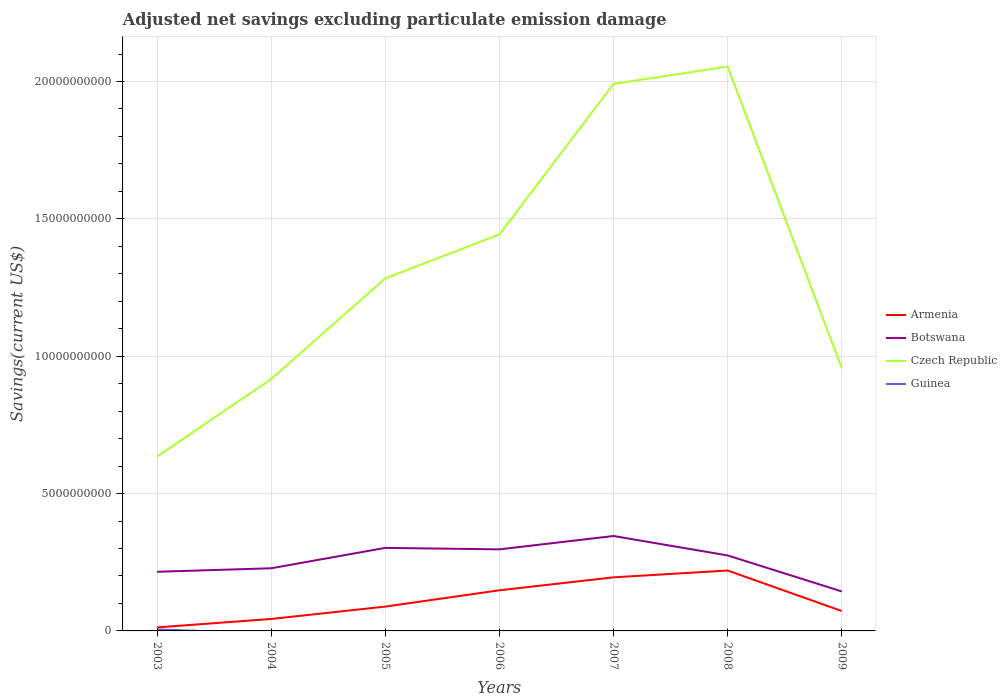How many different coloured lines are there?
Your answer should be very brief. 4. Is the number of lines equal to the number of legend labels?
Your response must be concise. No. Across all years, what is the maximum adjusted net savings in Botswana?
Provide a short and direct response. 1.44e+09. What is the total adjusted net savings in Armenia in the graph?
Provide a succinct answer. -7.58e+08. What is the difference between the highest and the second highest adjusted net savings in Czech Republic?
Provide a short and direct response. 1.42e+1. Is the adjusted net savings in Czech Republic strictly greater than the adjusted net savings in Armenia over the years?
Offer a very short reply. No. How many years are there in the graph?
Make the answer very short. 7. What is the difference between two consecutive major ticks on the Y-axis?
Offer a very short reply. 5.00e+09. Are the values on the major ticks of Y-axis written in scientific E-notation?
Your response must be concise. No. Does the graph contain any zero values?
Your answer should be very brief. Yes. Where does the legend appear in the graph?
Provide a short and direct response. Center right. How are the legend labels stacked?
Offer a very short reply. Vertical. What is the title of the graph?
Keep it short and to the point. Adjusted net savings excluding particulate emission damage. What is the label or title of the Y-axis?
Provide a succinct answer. Savings(current US$). What is the Savings(current US$) in Armenia in 2003?
Ensure brevity in your answer.  1.28e+08. What is the Savings(current US$) of Botswana in 2003?
Provide a succinct answer. 2.15e+09. What is the Savings(current US$) of Czech Republic in 2003?
Your response must be concise. 6.35e+09. What is the Savings(current US$) of Guinea in 2003?
Your answer should be compact. 5.63e+07. What is the Savings(current US$) in Armenia in 2004?
Provide a short and direct response. 4.36e+08. What is the Savings(current US$) of Botswana in 2004?
Provide a succinct answer. 2.28e+09. What is the Savings(current US$) in Czech Republic in 2004?
Your answer should be very brief. 9.17e+09. What is the Savings(current US$) of Armenia in 2005?
Give a very brief answer. 8.86e+08. What is the Savings(current US$) of Botswana in 2005?
Give a very brief answer. 3.02e+09. What is the Savings(current US$) of Czech Republic in 2005?
Your answer should be compact. 1.28e+1. What is the Savings(current US$) of Guinea in 2005?
Make the answer very short. 0. What is the Savings(current US$) in Armenia in 2006?
Ensure brevity in your answer.  1.48e+09. What is the Savings(current US$) of Botswana in 2006?
Provide a short and direct response. 2.97e+09. What is the Savings(current US$) in Czech Republic in 2006?
Give a very brief answer. 1.44e+1. What is the Savings(current US$) in Armenia in 2007?
Provide a short and direct response. 1.95e+09. What is the Savings(current US$) of Botswana in 2007?
Your response must be concise. 3.46e+09. What is the Savings(current US$) of Czech Republic in 2007?
Offer a terse response. 1.99e+1. What is the Savings(current US$) in Armenia in 2008?
Give a very brief answer. 2.20e+09. What is the Savings(current US$) in Botswana in 2008?
Your response must be concise. 2.75e+09. What is the Savings(current US$) of Czech Republic in 2008?
Keep it short and to the point. 2.05e+1. What is the Savings(current US$) in Armenia in 2009?
Offer a very short reply. 7.25e+08. What is the Savings(current US$) of Botswana in 2009?
Offer a terse response. 1.44e+09. What is the Savings(current US$) in Czech Republic in 2009?
Ensure brevity in your answer.  9.57e+09. What is the Savings(current US$) in Guinea in 2009?
Make the answer very short. 0. Across all years, what is the maximum Savings(current US$) of Armenia?
Your response must be concise. 2.20e+09. Across all years, what is the maximum Savings(current US$) in Botswana?
Provide a succinct answer. 3.46e+09. Across all years, what is the maximum Savings(current US$) of Czech Republic?
Your answer should be compact. 2.05e+1. Across all years, what is the maximum Savings(current US$) of Guinea?
Your response must be concise. 5.63e+07. Across all years, what is the minimum Savings(current US$) of Armenia?
Ensure brevity in your answer.  1.28e+08. Across all years, what is the minimum Savings(current US$) of Botswana?
Offer a terse response. 1.44e+09. Across all years, what is the minimum Savings(current US$) of Czech Republic?
Keep it short and to the point. 6.35e+09. Across all years, what is the minimum Savings(current US$) of Guinea?
Offer a very short reply. 0. What is the total Savings(current US$) in Armenia in the graph?
Give a very brief answer. 7.80e+09. What is the total Savings(current US$) in Botswana in the graph?
Offer a terse response. 1.81e+1. What is the total Savings(current US$) in Czech Republic in the graph?
Offer a terse response. 9.28e+1. What is the total Savings(current US$) in Guinea in the graph?
Your answer should be compact. 5.63e+07. What is the difference between the Savings(current US$) of Armenia in 2003 and that in 2004?
Make the answer very short. -3.08e+08. What is the difference between the Savings(current US$) of Botswana in 2003 and that in 2004?
Offer a terse response. -1.28e+08. What is the difference between the Savings(current US$) in Czech Republic in 2003 and that in 2004?
Your response must be concise. -2.82e+09. What is the difference between the Savings(current US$) in Armenia in 2003 and that in 2005?
Offer a very short reply. -7.58e+08. What is the difference between the Savings(current US$) in Botswana in 2003 and that in 2005?
Your response must be concise. -8.70e+08. What is the difference between the Savings(current US$) in Czech Republic in 2003 and that in 2005?
Your answer should be compact. -6.49e+09. What is the difference between the Savings(current US$) in Armenia in 2003 and that in 2006?
Make the answer very short. -1.35e+09. What is the difference between the Savings(current US$) in Botswana in 2003 and that in 2006?
Offer a terse response. -8.16e+08. What is the difference between the Savings(current US$) in Czech Republic in 2003 and that in 2006?
Give a very brief answer. -8.08e+09. What is the difference between the Savings(current US$) in Armenia in 2003 and that in 2007?
Your answer should be very brief. -1.82e+09. What is the difference between the Savings(current US$) in Botswana in 2003 and that in 2007?
Your answer should be very brief. -1.30e+09. What is the difference between the Savings(current US$) of Czech Republic in 2003 and that in 2007?
Your answer should be compact. -1.36e+1. What is the difference between the Savings(current US$) of Armenia in 2003 and that in 2008?
Keep it short and to the point. -2.07e+09. What is the difference between the Savings(current US$) in Botswana in 2003 and that in 2008?
Provide a short and direct response. -5.95e+08. What is the difference between the Savings(current US$) in Czech Republic in 2003 and that in 2008?
Provide a succinct answer. -1.42e+1. What is the difference between the Savings(current US$) in Armenia in 2003 and that in 2009?
Keep it short and to the point. -5.97e+08. What is the difference between the Savings(current US$) in Botswana in 2003 and that in 2009?
Your response must be concise. 7.15e+08. What is the difference between the Savings(current US$) of Czech Republic in 2003 and that in 2009?
Your answer should be very brief. -3.22e+09. What is the difference between the Savings(current US$) of Armenia in 2004 and that in 2005?
Your answer should be compact. -4.50e+08. What is the difference between the Savings(current US$) of Botswana in 2004 and that in 2005?
Keep it short and to the point. -7.42e+08. What is the difference between the Savings(current US$) of Czech Republic in 2004 and that in 2005?
Ensure brevity in your answer.  -3.66e+09. What is the difference between the Savings(current US$) of Armenia in 2004 and that in 2006?
Offer a very short reply. -1.04e+09. What is the difference between the Savings(current US$) of Botswana in 2004 and that in 2006?
Provide a short and direct response. -6.88e+08. What is the difference between the Savings(current US$) in Czech Republic in 2004 and that in 2006?
Provide a short and direct response. -5.26e+09. What is the difference between the Savings(current US$) of Armenia in 2004 and that in 2007?
Your response must be concise. -1.52e+09. What is the difference between the Savings(current US$) of Botswana in 2004 and that in 2007?
Ensure brevity in your answer.  -1.17e+09. What is the difference between the Savings(current US$) of Czech Republic in 2004 and that in 2007?
Make the answer very short. -1.07e+1. What is the difference between the Savings(current US$) in Armenia in 2004 and that in 2008?
Keep it short and to the point. -1.76e+09. What is the difference between the Savings(current US$) in Botswana in 2004 and that in 2008?
Your answer should be compact. -4.67e+08. What is the difference between the Savings(current US$) of Czech Republic in 2004 and that in 2008?
Provide a short and direct response. -1.14e+1. What is the difference between the Savings(current US$) of Armenia in 2004 and that in 2009?
Keep it short and to the point. -2.89e+08. What is the difference between the Savings(current US$) of Botswana in 2004 and that in 2009?
Make the answer very short. 8.43e+08. What is the difference between the Savings(current US$) of Czech Republic in 2004 and that in 2009?
Keep it short and to the point. -3.95e+08. What is the difference between the Savings(current US$) of Armenia in 2005 and that in 2006?
Make the answer very short. -5.93e+08. What is the difference between the Savings(current US$) of Botswana in 2005 and that in 2006?
Offer a very short reply. 5.38e+07. What is the difference between the Savings(current US$) in Czech Republic in 2005 and that in 2006?
Give a very brief answer. -1.60e+09. What is the difference between the Savings(current US$) in Armenia in 2005 and that in 2007?
Give a very brief answer. -1.06e+09. What is the difference between the Savings(current US$) in Botswana in 2005 and that in 2007?
Ensure brevity in your answer.  -4.32e+08. What is the difference between the Savings(current US$) of Czech Republic in 2005 and that in 2007?
Provide a succinct answer. -7.08e+09. What is the difference between the Savings(current US$) of Armenia in 2005 and that in 2008?
Your answer should be very brief. -1.31e+09. What is the difference between the Savings(current US$) of Botswana in 2005 and that in 2008?
Make the answer very short. 2.75e+08. What is the difference between the Savings(current US$) of Czech Republic in 2005 and that in 2008?
Offer a terse response. -7.71e+09. What is the difference between the Savings(current US$) in Armenia in 2005 and that in 2009?
Your response must be concise. 1.62e+08. What is the difference between the Savings(current US$) of Botswana in 2005 and that in 2009?
Your response must be concise. 1.59e+09. What is the difference between the Savings(current US$) of Czech Republic in 2005 and that in 2009?
Ensure brevity in your answer.  3.27e+09. What is the difference between the Savings(current US$) of Armenia in 2006 and that in 2007?
Provide a short and direct response. -4.72e+08. What is the difference between the Savings(current US$) of Botswana in 2006 and that in 2007?
Your answer should be very brief. -4.86e+08. What is the difference between the Savings(current US$) in Czech Republic in 2006 and that in 2007?
Your answer should be very brief. -5.48e+09. What is the difference between the Savings(current US$) in Armenia in 2006 and that in 2008?
Ensure brevity in your answer.  -7.20e+08. What is the difference between the Savings(current US$) of Botswana in 2006 and that in 2008?
Offer a terse response. 2.21e+08. What is the difference between the Savings(current US$) in Czech Republic in 2006 and that in 2008?
Offer a very short reply. -6.11e+09. What is the difference between the Savings(current US$) of Armenia in 2006 and that in 2009?
Give a very brief answer. 7.54e+08. What is the difference between the Savings(current US$) of Botswana in 2006 and that in 2009?
Your answer should be very brief. 1.53e+09. What is the difference between the Savings(current US$) in Czech Republic in 2006 and that in 2009?
Provide a short and direct response. 4.87e+09. What is the difference between the Savings(current US$) in Armenia in 2007 and that in 2008?
Keep it short and to the point. -2.48e+08. What is the difference between the Savings(current US$) of Botswana in 2007 and that in 2008?
Make the answer very short. 7.07e+08. What is the difference between the Savings(current US$) in Czech Republic in 2007 and that in 2008?
Offer a very short reply. -6.28e+08. What is the difference between the Savings(current US$) in Armenia in 2007 and that in 2009?
Your answer should be very brief. 1.23e+09. What is the difference between the Savings(current US$) of Botswana in 2007 and that in 2009?
Give a very brief answer. 2.02e+09. What is the difference between the Savings(current US$) of Czech Republic in 2007 and that in 2009?
Your response must be concise. 1.03e+1. What is the difference between the Savings(current US$) in Armenia in 2008 and that in 2009?
Provide a short and direct response. 1.47e+09. What is the difference between the Savings(current US$) in Botswana in 2008 and that in 2009?
Make the answer very short. 1.31e+09. What is the difference between the Savings(current US$) of Czech Republic in 2008 and that in 2009?
Give a very brief answer. 1.10e+1. What is the difference between the Savings(current US$) in Armenia in 2003 and the Savings(current US$) in Botswana in 2004?
Give a very brief answer. -2.15e+09. What is the difference between the Savings(current US$) in Armenia in 2003 and the Savings(current US$) in Czech Republic in 2004?
Offer a terse response. -9.04e+09. What is the difference between the Savings(current US$) of Botswana in 2003 and the Savings(current US$) of Czech Republic in 2004?
Your answer should be compact. -7.02e+09. What is the difference between the Savings(current US$) of Armenia in 2003 and the Savings(current US$) of Botswana in 2005?
Your response must be concise. -2.90e+09. What is the difference between the Savings(current US$) of Armenia in 2003 and the Savings(current US$) of Czech Republic in 2005?
Your answer should be compact. -1.27e+1. What is the difference between the Savings(current US$) in Botswana in 2003 and the Savings(current US$) in Czech Republic in 2005?
Make the answer very short. -1.07e+1. What is the difference between the Savings(current US$) in Armenia in 2003 and the Savings(current US$) in Botswana in 2006?
Give a very brief answer. -2.84e+09. What is the difference between the Savings(current US$) in Armenia in 2003 and the Savings(current US$) in Czech Republic in 2006?
Offer a terse response. -1.43e+1. What is the difference between the Savings(current US$) in Botswana in 2003 and the Savings(current US$) in Czech Republic in 2006?
Your answer should be compact. -1.23e+1. What is the difference between the Savings(current US$) of Armenia in 2003 and the Savings(current US$) of Botswana in 2007?
Provide a short and direct response. -3.33e+09. What is the difference between the Savings(current US$) of Armenia in 2003 and the Savings(current US$) of Czech Republic in 2007?
Provide a short and direct response. -1.98e+1. What is the difference between the Savings(current US$) in Botswana in 2003 and the Savings(current US$) in Czech Republic in 2007?
Give a very brief answer. -1.78e+1. What is the difference between the Savings(current US$) of Armenia in 2003 and the Savings(current US$) of Botswana in 2008?
Offer a terse response. -2.62e+09. What is the difference between the Savings(current US$) of Armenia in 2003 and the Savings(current US$) of Czech Republic in 2008?
Ensure brevity in your answer.  -2.04e+1. What is the difference between the Savings(current US$) of Botswana in 2003 and the Savings(current US$) of Czech Republic in 2008?
Make the answer very short. -1.84e+1. What is the difference between the Savings(current US$) of Armenia in 2003 and the Savings(current US$) of Botswana in 2009?
Your answer should be compact. -1.31e+09. What is the difference between the Savings(current US$) of Armenia in 2003 and the Savings(current US$) of Czech Republic in 2009?
Offer a terse response. -9.44e+09. What is the difference between the Savings(current US$) of Botswana in 2003 and the Savings(current US$) of Czech Republic in 2009?
Ensure brevity in your answer.  -7.41e+09. What is the difference between the Savings(current US$) in Armenia in 2004 and the Savings(current US$) in Botswana in 2005?
Offer a terse response. -2.59e+09. What is the difference between the Savings(current US$) of Armenia in 2004 and the Savings(current US$) of Czech Republic in 2005?
Provide a succinct answer. -1.24e+1. What is the difference between the Savings(current US$) in Botswana in 2004 and the Savings(current US$) in Czech Republic in 2005?
Ensure brevity in your answer.  -1.06e+1. What is the difference between the Savings(current US$) of Armenia in 2004 and the Savings(current US$) of Botswana in 2006?
Your answer should be compact. -2.53e+09. What is the difference between the Savings(current US$) in Armenia in 2004 and the Savings(current US$) in Czech Republic in 2006?
Provide a succinct answer. -1.40e+1. What is the difference between the Savings(current US$) of Botswana in 2004 and the Savings(current US$) of Czech Republic in 2006?
Give a very brief answer. -1.22e+1. What is the difference between the Savings(current US$) in Armenia in 2004 and the Savings(current US$) in Botswana in 2007?
Make the answer very short. -3.02e+09. What is the difference between the Savings(current US$) in Armenia in 2004 and the Savings(current US$) in Czech Republic in 2007?
Ensure brevity in your answer.  -1.95e+1. What is the difference between the Savings(current US$) in Botswana in 2004 and the Savings(current US$) in Czech Republic in 2007?
Give a very brief answer. -1.76e+1. What is the difference between the Savings(current US$) in Armenia in 2004 and the Savings(current US$) in Botswana in 2008?
Make the answer very short. -2.31e+09. What is the difference between the Savings(current US$) of Armenia in 2004 and the Savings(current US$) of Czech Republic in 2008?
Your answer should be compact. -2.01e+1. What is the difference between the Savings(current US$) in Botswana in 2004 and the Savings(current US$) in Czech Republic in 2008?
Your answer should be very brief. -1.83e+1. What is the difference between the Savings(current US$) in Armenia in 2004 and the Savings(current US$) in Botswana in 2009?
Offer a terse response. -1.00e+09. What is the difference between the Savings(current US$) of Armenia in 2004 and the Savings(current US$) of Czech Republic in 2009?
Make the answer very short. -9.13e+09. What is the difference between the Savings(current US$) of Botswana in 2004 and the Savings(current US$) of Czech Republic in 2009?
Offer a terse response. -7.29e+09. What is the difference between the Savings(current US$) of Armenia in 2005 and the Savings(current US$) of Botswana in 2006?
Offer a very short reply. -2.08e+09. What is the difference between the Savings(current US$) of Armenia in 2005 and the Savings(current US$) of Czech Republic in 2006?
Give a very brief answer. -1.35e+1. What is the difference between the Savings(current US$) of Botswana in 2005 and the Savings(current US$) of Czech Republic in 2006?
Ensure brevity in your answer.  -1.14e+1. What is the difference between the Savings(current US$) of Armenia in 2005 and the Savings(current US$) of Botswana in 2007?
Your answer should be very brief. -2.57e+09. What is the difference between the Savings(current US$) of Armenia in 2005 and the Savings(current US$) of Czech Republic in 2007?
Offer a very short reply. -1.90e+1. What is the difference between the Savings(current US$) of Botswana in 2005 and the Savings(current US$) of Czech Republic in 2007?
Give a very brief answer. -1.69e+1. What is the difference between the Savings(current US$) of Armenia in 2005 and the Savings(current US$) of Botswana in 2008?
Ensure brevity in your answer.  -1.86e+09. What is the difference between the Savings(current US$) of Armenia in 2005 and the Savings(current US$) of Czech Republic in 2008?
Give a very brief answer. -1.97e+1. What is the difference between the Savings(current US$) in Botswana in 2005 and the Savings(current US$) in Czech Republic in 2008?
Provide a succinct answer. -1.75e+1. What is the difference between the Savings(current US$) of Armenia in 2005 and the Savings(current US$) of Botswana in 2009?
Your response must be concise. -5.52e+08. What is the difference between the Savings(current US$) in Armenia in 2005 and the Savings(current US$) in Czech Republic in 2009?
Your response must be concise. -8.68e+09. What is the difference between the Savings(current US$) in Botswana in 2005 and the Savings(current US$) in Czech Republic in 2009?
Provide a short and direct response. -6.54e+09. What is the difference between the Savings(current US$) of Armenia in 2006 and the Savings(current US$) of Botswana in 2007?
Offer a very short reply. -1.98e+09. What is the difference between the Savings(current US$) in Armenia in 2006 and the Savings(current US$) in Czech Republic in 2007?
Your answer should be compact. -1.84e+1. What is the difference between the Savings(current US$) in Botswana in 2006 and the Savings(current US$) in Czech Republic in 2007?
Make the answer very short. -1.69e+1. What is the difference between the Savings(current US$) of Armenia in 2006 and the Savings(current US$) of Botswana in 2008?
Your response must be concise. -1.27e+09. What is the difference between the Savings(current US$) in Armenia in 2006 and the Savings(current US$) in Czech Republic in 2008?
Keep it short and to the point. -1.91e+1. What is the difference between the Savings(current US$) of Botswana in 2006 and the Savings(current US$) of Czech Republic in 2008?
Give a very brief answer. -1.76e+1. What is the difference between the Savings(current US$) of Armenia in 2006 and the Savings(current US$) of Botswana in 2009?
Offer a terse response. 4.10e+07. What is the difference between the Savings(current US$) of Armenia in 2006 and the Savings(current US$) of Czech Republic in 2009?
Provide a short and direct response. -8.09e+09. What is the difference between the Savings(current US$) in Botswana in 2006 and the Savings(current US$) in Czech Republic in 2009?
Make the answer very short. -6.60e+09. What is the difference between the Savings(current US$) of Armenia in 2007 and the Savings(current US$) of Botswana in 2008?
Make the answer very short. -7.97e+08. What is the difference between the Savings(current US$) of Armenia in 2007 and the Savings(current US$) of Czech Republic in 2008?
Make the answer very short. -1.86e+1. What is the difference between the Savings(current US$) in Botswana in 2007 and the Savings(current US$) in Czech Republic in 2008?
Make the answer very short. -1.71e+1. What is the difference between the Savings(current US$) in Armenia in 2007 and the Savings(current US$) in Botswana in 2009?
Offer a terse response. 5.13e+08. What is the difference between the Savings(current US$) of Armenia in 2007 and the Savings(current US$) of Czech Republic in 2009?
Provide a succinct answer. -7.62e+09. What is the difference between the Savings(current US$) of Botswana in 2007 and the Savings(current US$) of Czech Republic in 2009?
Your response must be concise. -6.11e+09. What is the difference between the Savings(current US$) of Armenia in 2008 and the Savings(current US$) of Botswana in 2009?
Make the answer very short. 7.61e+08. What is the difference between the Savings(current US$) of Armenia in 2008 and the Savings(current US$) of Czech Republic in 2009?
Your answer should be very brief. -7.37e+09. What is the difference between the Savings(current US$) of Botswana in 2008 and the Savings(current US$) of Czech Republic in 2009?
Offer a very short reply. -6.82e+09. What is the average Savings(current US$) in Armenia per year?
Your answer should be compact. 1.11e+09. What is the average Savings(current US$) in Botswana per year?
Your answer should be compact. 2.58e+09. What is the average Savings(current US$) of Czech Republic per year?
Your answer should be very brief. 1.33e+1. What is the average Savings(current US$) of Guinea per year?
Provide a short and direct response. 8.04e+06. In the year 2003, what is the difference between the Savings(current US$) in Armenia and Savings(current US$) in Botswana?
Ensure brevity in your answer.  -2.02e+09. In the year 2003, what is the difference between the Savings(current US$) in Armenia and Savings(current US$) in Czech Republic?
Ensure brevity in your answer.  -6.22e+09. In the year 2003, what is the difference between the Savings(current US$) in Armenia and Savings(current US$) in Guinea?
Make the answer very short. 7.17e+07. In the year 2003, what is the difference between the Savings(current US$) in Botswana and Savings(current US$) in Czech Republic?
Your response must be concise. -4.20e+09. In the year 2003, what is the difference between the Savings(current US$) of Botswana and Savings(current US$) of Guinea?
Keep it short and to the point. 2.10e+09. In the year 2003, what is the difference between the Savings(current US$) of Czech Republic and Savings(current US$) of Guinea?
Offer a very short reply. 6.29e+09. In the year 2004, what is the difference between the Savings(current US$) in Armenia and Savings(current US$) in Botswana?
Keep it short and to the point. -1.85e+09. In the year 2004, what is the difference between the Savings(current US$) of Armenia and Savings(current US$) of Czech Republic?
Give a very brief answer. -8.74e+09. In the year 2004, what is the difference between the Savings(current US$) in Botswana and Savings(current US$) in Czech Republic?
Offer a terse response. -6.89e+09. In the year 2005, what is the difference between the Savings(current US$) of Armenia and Savings(current US$) of Botswana?
Provide a short and direct response. -2.14e+09. In the year 2005, what is the difference between the Savings(current US$) of Armenia and Savings(current US$) of Czech Republic?
Provide a short and direct response. -1.19e+1. In the year 2005, what is the difference between the Savings(current US$) in Botswana and Savings(current US$) in Czech Republic?
Your response must be concise. -9.81e+09. In the year 2006, what is the difference between the Savings(current US$) in Armenia and Savings(current US$) in Botswana?
Your response must be concise. -1.49e+09. In the year 2006, what is the difference between the Savings(current US$) of Armenia and Savings(current US$) of Czech Republic?
Your response must be concise. -1.30e+1. In the year 2006, what is the difference between the Savings(current US$) of Botswana and Savings(current US$) of Czech Republic?
Ensure brevity in your answer.  -1.15e+1. In the year 2007, what is the difference between the Savings(current US$) in Armenia and Savings(current US$) in Botswana?
Give a very brief answer. -1.50e+09. In the year 2007, what is the difference between the Savings(current US$) in Armenia and Savings(current US$) in Czech Republic?
Provide a short and direct response. -1.80e+1. In the year 2007, what is the difference between the Savings(current US$) in Botswana and Savings(current US$) in Czech Republic?
Provide a short and direct response. -1.65e+1. In the year 2008, what is the difference between the Savings(current US$) of Armenia and Savings(current US$) of Botswana?
Your response must be concise. -5.49e+08. In the year 2008, what is the difference between the Savings(current US$) in Armenia and Savings(current US$) in Czech Republic?
Offer a very short reply. -1.83e+1. In the year 2008, what is the difference between the Savings(current US$) of Botswana and Savings(current US$) of Czech Republic?
Your response must be concise. -1.78e+1. In the year 2009, what is the difference between the Savings(current US$) of Armenia and Savings(current US$) of Botswana?
Offer a very short reply. -7.13e+08. In the year 2009, what is the difference between the Savings(current US$) in Armenia and Savings(current US$) in Czech Republic?
Make the answer very short. -8.84e+09. In the year 2009, what is the difference between the Savings(current US$) in Botswana and Savings(current US$) in Czech Republic?
Your answer should be compact. -8.13e+09. What is the ratio of the Savings(current US$) of Armenia in 2003 to that in 2004?
Offer a terse response. 0.29. What is the ratio of the Savings(current US$) of Botswana in 2003 to that in 2004?
Provide a succinct answer. 0.94. What is the ratio of the Savings(current US$) in Czech Republic in 2003 to that in 2004?
Make the answer very short. 0.69. What is the ratio of the Savings(current US$) of Armenia in 2003 to that in 2005?
Keep it short and to the point. 0.14. What is the ratio of the Savings(current US$) of Botswana in 2003 to that in 2005?
Make the answer very short. 0.71. What is the ratio of the Savings(current US$) of Czech Republic in 2003 to that in 2005?
Give a very brief answer. 0.49. What is the ratio of the Savings(current US$) of Armenia in 2003 to that in 2006?
Make the answer very short. 0.09. What is the ratio of the Savings(current US$) of Botswana in 2003 to that in 2006?
Your answer should be very brief. 0.72. What is the ratio of the Savings(current US$) of Czech Republic in 2003 to that in 2006?
Your answer should be compact. 0.44. What is the ratio of the Savings(current US$) in Armenia in 2003 to that in 2007?
Make the answer very short. 0.07. What is the ratio of the Savings(current US$) in Botswana in 2003 to that in 2007?
Your answer should be very brief. 0.62. What is the ratio of the Savings(current US$) in Czech Republic in 2003 to that in 2007?
Your response must be concise. 0.32. What is the ratio of the Savings(current US$) in Armenia in 2003 to that in 2008?
Make the answer very short. 0.06. What is the ratio of the Savings(current US$) of Botswana in 2003 to that in 2008?
Offer a very short reply. 0.78. What is the ratio of the Savings(current US$) of Czech Republic in 2003 to that in 2008?
Your answer should be very brief. 0.31. What is the ratio of the Savings(current US$) of Armenia in 2003 to that in 2009?
Make the answer very short. 0.18. What is the ratio of the Savings(current US$) in Botswana in 2003 to that in 2009?
Offer a terse response. 1.5. What is the ratio of the Savings(current US$) of Czech Republic in 2003 to that in 2009?
Offer a terse response. 0.66. What is the ratio of the Savings(current US$) in Armenia in 2004 to that in 2005?
Offer a terse response. 0.49. What is the ratio of the Savings(current US$) of Botswana in 2004 to that in 2005?
Make the answer very short. 0.75. What is the ratio of the Savings(current US$) in Czech Republic in 2004 to that in 2005?
Offer a very short reply. 0.71. What is the ratio of the Savings(current US$) in Armenia in 2004 to that in 2006?
Provide a short and direct response. 0.29. What is the ratio of the Savings(current US$) in Botswana in 2004 to that in 2006?
Your response must be concise. 0.77. What is the ratio of the Savings(current US$) in Czech Republic in 2004 to that in 2006?
Provide a short and direct response. 0.64. What is the ratio of the Savings(current US$) of Armenia in 2004 to that in 2007?
Provide a short and direct response. 0.22. What is the ratio of the Savings(current US$) of Botswana in 2004 to that in 2007?
Give a very brief answer. 0.66. What is the ratio of the Savings(current US$) in Czech Republic in 2004 to that in 2007?
Your response must be concise. 0.46. What is the ratio of the Savings(current US$) of Armenia in 2004 to that in 2008?
Your answer should be very brief. 0.2. What is the ratio of the Savings(current US$) of Botswana in 2004 to that in 2008?
Make the answer very short. 0.83. What is the ratio of the Savings(current US$) in Czech Republic in 2004 to that in 2008?
Offer a terse response. 0.45. What is the ratio of the Savings(current US$) of Armenia in 2004 to that in 2009?
Offer a very short reply. 0.6. What is the ratio of the Savings(current US$) of Botswana in 2004 to that in 2009?
Offer a terse response. 1.59. What is the ratio of the Savings(current US$) of Czech Republic in 2004 to that in 2009?
Provide a succinct answer. 0.96. What is the ratio of the Savings(current US$) in Armenia in 2005 to that in 2006?
Provide a succinct answer. 0.6. What is the ratio of the Savings(current US$) in Botswana in 2005 to that in 2006?
Keep it short and to the point. 1.02. What is the ratio of the Savings(current US$) in Czech Republic in 2005 to that in 2006?
Your answer should be compact. 0.89. What is the ratio of the Savings(current US$) of Armenia in 2005 to that in 2007?
Give a very brief answer. 0.45. What is the ratio of the Savings(current US$) in Botswana in 2005 to that in 2007?
Your answer should be very brief. 0.87. What is the ratio of the Savings(current US$) in Czech Republic in 2005 to that in 2007?
Ensure brevity in your answer.  0.64. What is the ratio of the Savings(current US$) of Armenia in 2005 to that in 2008?
Keep it short and to the point. 0.4. What is the ratio of the Savings(current US$) of Botswana in 2005 to that in 2008?
Offer a very short reply. 1.1. What is the ratio of the Savings(current US$) in Czech Republic in 2005 to that in 2008?
Offer a terse response. 0.62. What is the ratio of the Savings(current US$) in Armenia in 2005 to that in 2009?
Make the answer very short. 1.22. What is the ratio of the Savings(current US$) in Botswana in 2005 to that in 2009?
Provide a succinct answer. 2.1. What is the ratio of the Savings(current US$) of Czech Republic in 2005 to that in 2009?
Make the answer very short. 1.34. What is the ratio of the Savings(current US$) of Armenia in 2006 to that in 2007?
Give a very brief answer. 0.76. What is the ratio of the Savings(current US$) in Botswana in 2006 to that in 2007?
Ensure brevity in your answer.  0.86. What is the ratio of the Savings(current US$) of Czech Republic in 2006 to that in 2007?
Your response must be concise. 0.72. What is the ratio of the Savings(current US$) of Armenia in 2006 to that in 2008?
Offer a terse response. 0.67. What is the ratio of the Savings(current US$) in Botswana in 2006 to that in 2008?
Your answer should be very brief. 1.08. What is the ratio of the Savings(current US$) in Czech Republic in 2006 to that in 2008?
Make the answer very short. 0.7. What is the ratio of the Savings(current US$) of Armenia in 2006 to that in 2009?
Keep it short and to the point. 2.04. What is the ratio of the Savings(current US$) in Botswana in 2006 to that in 2009?
Provide a short and direct response. 2.06. What is the ratio of the Savings(current US$) of Czech Republic in 2006 to that in 2009?
Your answer should be very brief. 1.51. What is the ratio of the Savings(current US$) in Armenia in 2007 to that in 2008?
Provide a succinct answer. 0.89. What is the ratio of the Savings(current US$) of Botswana in 2007 to that in 2008?
Provide a short and direct response. 1.26. What is the ratio of the Savings(current US$) of Czech Republic in 2007 to that in 2008?
Give a very brief answer. 0.97. What is the ratio of the Savings(current US$) in Armenia in 2007 to that in 2009?
Offer a very short reply. 2.69. What is the ratio of the Savings(current US$) in Botswana in 2007 to that in 2009?
Give a very brief answer. 2.4. What is the ratio of the Savings(current US$) of Czech Republic in 2007 to that in 2009?
Make the answer very short. 2.08. What is the ratio of the Savings(current US$) in Armenia in 2008 to that in 2009?
Provide a short and direct response. 3.03. What is the ratio of the Savings(current US$) in Botswana in 2008 to that in 2009?
Give a very brief answer. 1.91. What is the ratio of the Savings(current US$) of Czech Republic in 2008 to that in 2009?
Keep it short and to the point. 2.15. What is the difference between the highest and the second highest Savings(current US$) of Armenia?
Keep it short and to the point. 2.48e+08. What is the difference between the highest and the second highest Savings(current US$) of Botswana?
Provide a short and direct response. 4.32e+08. What is the difference between the highest and the second highest Savings(current US$) in Czech Republic?
Provide a short and direct response. 6.28e+08. What is the difference between the highest and the lowest Savings(current US$) of Armenia?
Ensure brevity in your answer.  2.07e+09. What is the difference between the highest and the lowest Savings(current US$) in Botswana?
Your answer should be very brief. 2.02e+09. What is the difference between the highest and the lowest Savings(current US$) of Czech Republic?
Ensure brevity in your answer.  1.42e+1. What is the difference between the highest and the lowest Savings(current US$) of Guinea?
Your answer should be very brief. 5.63e+07. 